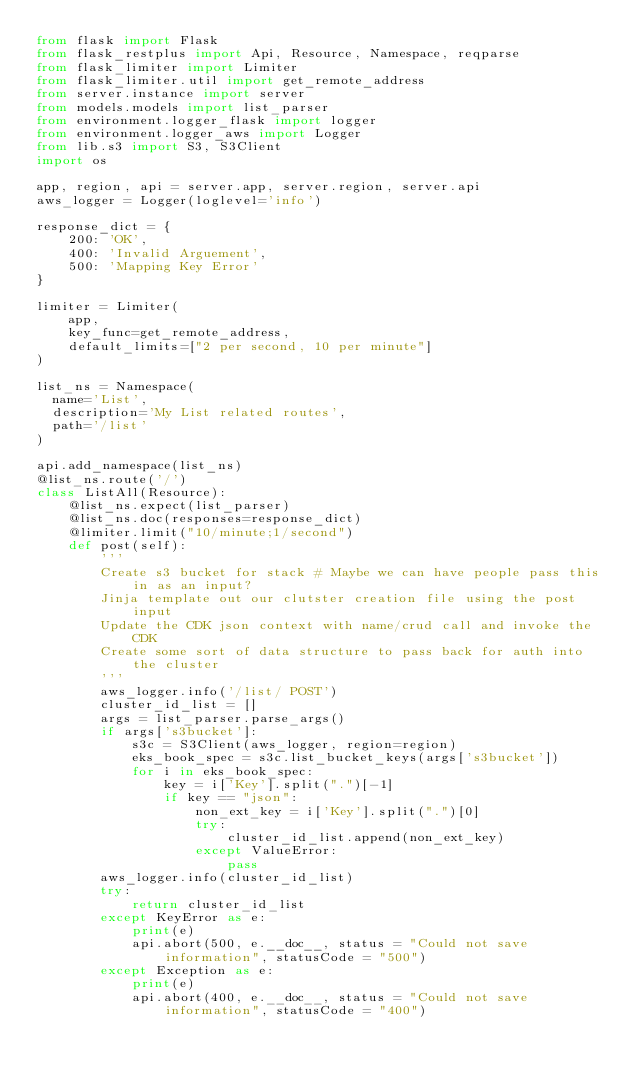Convert code to text. <code><loc_0><loc_0><loc_500><loc_500><_Python_>from flask import Flask
from flask_restplus import Api, Resource, Namespace, reqparse
from flask_limiter import Limiter
from flask_limiter.util import get_remote_address
from server.instance import server
from models.models import list_parser
from environment.logger_flask import logger
from environment.logger_aws import Logger
from lib.s3 import S3, S3Client
import os

app, region, api = server.app, server.region, server.api
aws_logger = Logger(loglevel='info')

response_dict = {
    200: 'OK',
    400: 'Invalid Arguement',
    500: 'Mapping Key Error'
}

limiter = Limiter(
    app,
    key_func=get_remote_address,
    default_limits=["2 per second, 10 per minute"]
)

list_ns = Namespace(
  name='List',
  description='My List related routes',
  path='/list'
)

api.add_namespace(list_ns)
@list_ns.route('/')
class ListAll(Resource):
    @list_ns.expect(list_parser)
    @list_ns.doc(responses=response_dict)
    @limiter.limit("10/minute;1/second")
    def post(self):
        '''
        Create s3 bucket for stack # Maybe we can have people pass this in as an input?
        Jinja template out our clutster creation file using the post input
        Update the CDK json context with name/crud call and invoke the CDK
        Create some sort of data structure to pass back for auth into the cluster
        '''
        aws_logger.info('/list/ POST')
        cluster_id_list = []
        args = list_parser.parse_args()
        if args['s3bucket']:
            s3c = S3Client(aws_logger, region=region)
            eks_book_spec = s3c.list_bucket_keys(args['s3bucket'])
            for i in eks_book_spec:
                key = i['Key'].split(".")[-1]
                if key == "json":
                    non_ext_key = i['Key'].split(".")[0]
                    try:
                        cluster_id_list.append(non_ext_key)
                    except ValueError:
                        pass
        aws_logger.info(cluster_id_list)
        try:
            return cluster_id_list
        except KeyError as e:
            print(e)
            api.abort(500, e.__doc__, status = "Could not save information", statusCode = "500")
        except Exception as e:
            print(e)
            api.abort(400, e.__doc__, status = "Could not save information", statusCode = "400")
</code> 